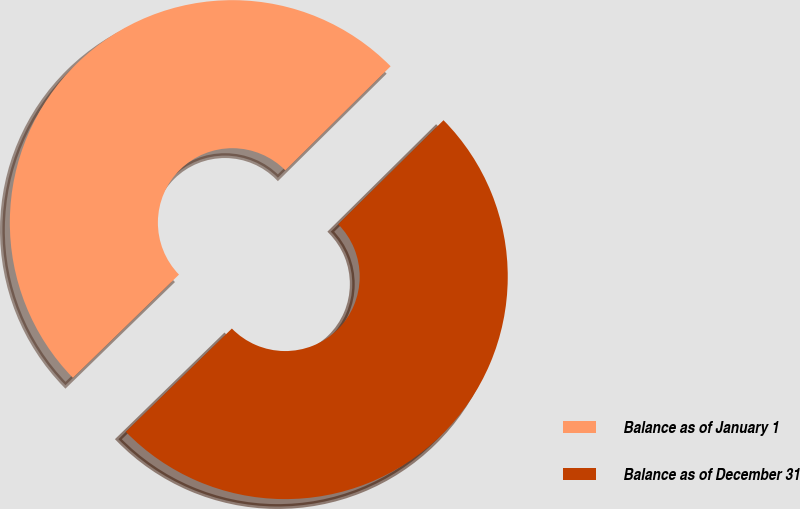<chart> <loc_0><loc_0><loc_500><loc_500><pie_chart><fcel>Balance as of January 1<fcel>Balance as of December 31<nl><fcel>49.88%<fcel>50.12%<nl></chart> 